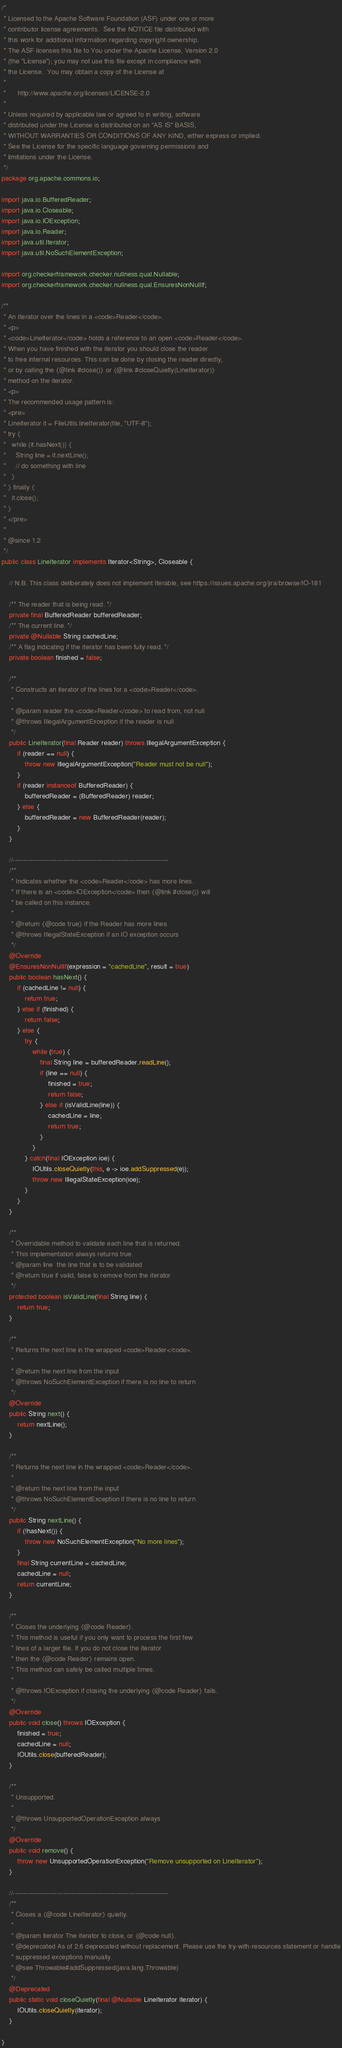<code> <loc_0><loc_0><loc_500><loc_500><_Java_>/*
 * Licensed to the Apache Software Foundation (ASF) under one or more
 * contributor license agreements.  See the NOTICE file distributed with
 * this work for additional information regarding copyright ownership.
 * The ASF licenses this file to You under the Apache License, Version 2.0
 * (the "License"); you may not use this file except in compliance with
 * the License.  You may obtain a copy of the License at
 *
 *      http://www.apache.org/licenses/LICENSE-2.0
 *
 * Unless required by applicable law or agreed to in writing, software
 * distributed under the License is distributed on an "AS IS" BASIS,
 * WITHOUT WARRANTIES OR CONDITIONS OF ANY KIND, either express or implied.
 * See the License for the specific language governing permissions and
 * limitations under the License.
 */
package org.apache.commons.io;

import java.io.BufferedReader;
import java.io.Closeable;
import java.io.IOException;
import java.io.Reader;
import java.util.Iterator;
import java.util.NoSuchElementException;

import org.checkerframework.checker.nullness.qual.Nullable;
import org.checkerframework.checker.nullness.qual.EnsuresNonNullIf;

/**
 * An Iterator over the lines in a <code>Reader</code>.
 * <p>
 * <code>LineIterator</code> holds a reference to an open <code>Reader</code>.
 * When you have finished with the iterator you should close the reader
 * to free internal resources. This can be done by closing the reader directly,
 * or by calling the {@link #close()} or {@link #closeQuietly(LineIterator)}
 * method on the iterator.
 * <p>
 * The recommended usage pattern is:
 * <pre>
 * LineIterator it = FileUtils.lineIterator(file, "UTF-8");
 * try {
 *   while (it.hasNext()) {
 *     String line = it.nextLine();
 *     // do something with line
 *   }
 * } finally {
 *   it.close();
 * }
 * </pre>
 *
 * @since 1.2
 */
public class LineIterator implements Iterator<String>, Closeable {

    // N.B. This class deliberately does not implement Iterable, see https://issues.apache.org/jira/browse/IO-181

    /** The reader that is being read. */
    private final BufferedReader bufferedReader;
    /** The current line. */
    private @Nullable String cachedLine;
    /** A flag indicating if the iterator has been fully read. */
    private boolean finished = false;

    /**
     * Constructs an iterator of the lines for a <code>Reader</code>.
     *
     * @param reader the <code>Reader</code> to read from, not null
     * @throws IllegalArgumentException if the reader is null
     */
    public LineIterator(final Reader reader) throws IllegalArgumentException {
        if (reader == null) {
            throw new IllegalArgumentException("Reader must not be null");
        }
        if (reader instanceof BufferedReader) {
            bufferedReader = (BufferedReader) reader;
        } else {
            bufferedReader = new BufferedReader(reader);
        }
    }

    //-----------------------------------------------------------------------
    /**
     * Indicates whether the <code>Reader</code> has more lines.
     * If there is an <code>IOException</code> then {@link #close()} will
     * be called on this instance.
     *
     * @return {@code true} if the Reader has more lines
     * @throws IllegalStateException if an IO exception occurs
     */
    @Override
    @EnsuresNonNullIf(expression = "cachedLine", result = true)
    public boolean hasNext() {
        if (cachedLine != null) {
            return true;
        } else if (finished) {
            return false;
        } else {
            try {
                while (true) {
                    final String line = bufferedReader.readLine();
                    if (line == null) {
                        finished = true;
                        return false;
                    } else if (isValidLine(line)) {
                        cachedLine = line;
                        return true;
                    }
                }
            } catch(final IOException ioe) {
                IOUtils.closeQuietly(this, e -> ioe.addSuppressed(e));
                throw new IllegalStateException(ioe);
            }
        }
    }

    /**
     * Overridable method to validate each line that is returned.
     * This implementation always returns true.
     * @param line  the line that is to be validated
     * @return true if valid, false to remove from the iterator
     */
    protected boolean isValidLine(final String line) {
        return true;
    }

    /**
     * Returns the next line in the wrapped <code>Reader</code>.
     *
     * @return the next line from the input
     * @throws NoSuchElementException if there is no line to return
     */
    @Override
    public String next() {
        return nextLine();
    }

    /**
     * Returns the next line in the wrapped <code>Reader</code>.
     *
     * @return the next line from the input
     * @throws NoSuchElementException if there is no line to return
     */
    public String nextLine() {
        if (!hasNext()) {
            throw new NoSuchElementException("No more lines");
        }
        final String currentLine = cachedLine;
        cachedLine = null;
        return currentLine;
    }

    /**
     * Closes the underlying {@code Reader}.
     * This method is useful if you only want to process the first few
     * lines of a larger file. If you do not close the iterator
     * then the {@code Reader} remains open.
     * This method can safely be called multiple times.
     *
     * @throws IOException if closing the underlying {@code Reader} fails.
     */
    @Override
    public void close() throws IOException {
        finished = true;
        cachedLine = null;
        IOUtils.close(bufferedReader);
    }

    /**
     * Unsupported.
     *
     * @throws UnsupportedOperationException always
     */
    @Override
    public void remove() {
        throw new UnsupportedOperationException("Remove unsupported on LineIterator");
    }

    //-----------------------------------------------------------------------
    /**
     * Closes a {@code LineIterator} quietly.
     *
     * @param iterator The iterator to close, or {@code null}.
     * @deprecated As of 2.6 deprecated without replacement. Please use the try-with-resources statement or handle
     * suppressed exceptions manually.
     * @see Throwable#addSuppressed(java.lang.Throwable)
     */
    @Deprecated
    public static void closeQuietly(final @Nullable LineIterator iterator) {
        IOUtils.closeQuietly(iterator);
    }

}
</code> 